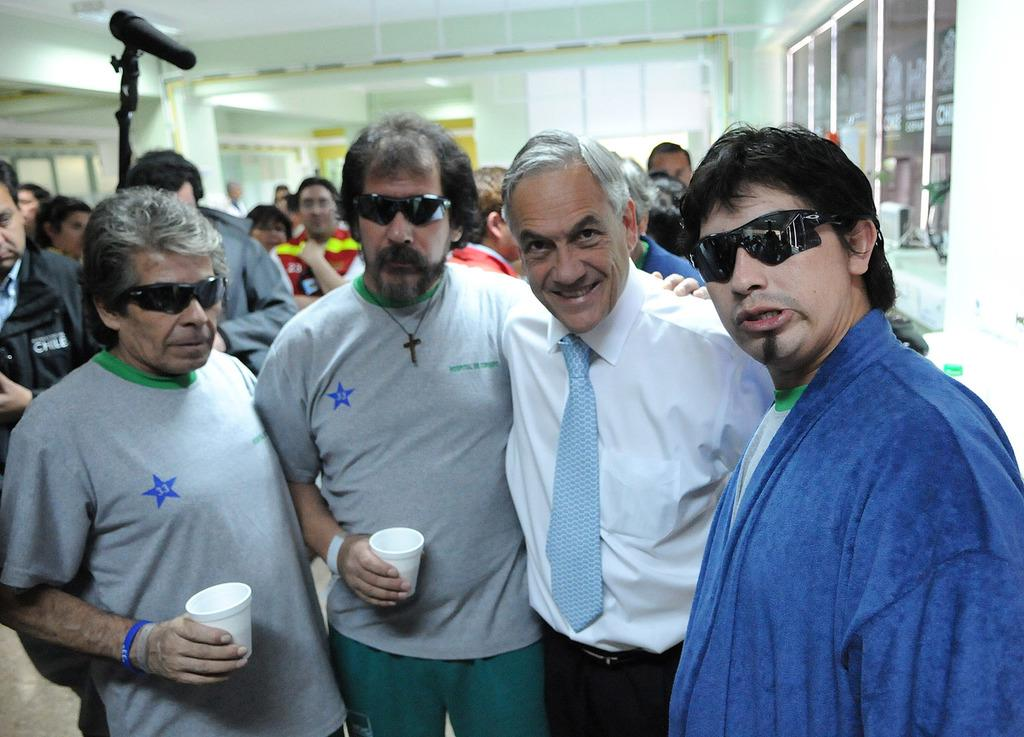How many people are present in the image? There are four people standing in the image. What are two of the people holding? Two of the people are holding cups. Can you describe the background of the image? There are people visible in the background of the image, along with a microphone with a stand and a glass. What type of sheet is being used to play the bells in the image? There are no bells or sheets present in the image. 